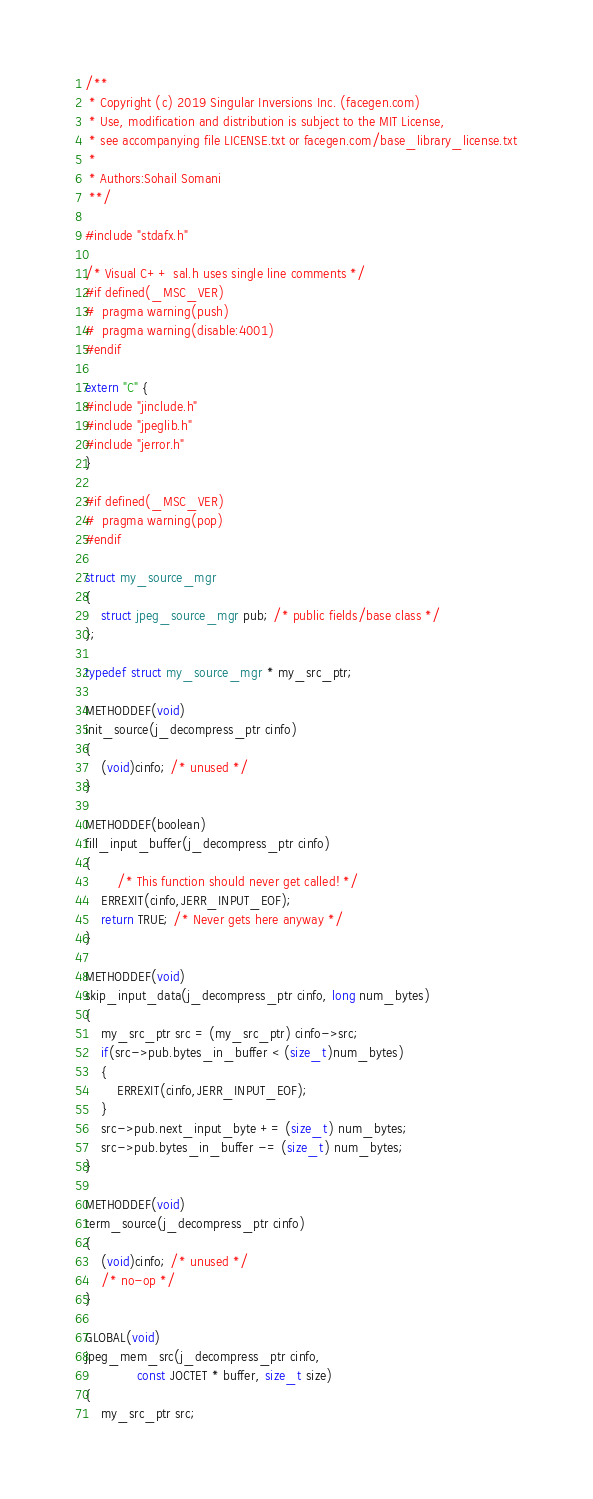<code> <loc_0><loc_0><loc_500><loc_500><_C++_>/**
 * Copyright (c) 2019 Singular Inversions Inc. (facegen.com)
 * Use, modification and distribution is subject to the MIT License,
 * see accompanying file LICENSE.txt or facegen.com/base_library_license.txt
 *
 * Authors:Sohail Somani
 **/

#include "stdafx.h"

/* Visual C++ sal.h uses single line comments */
#if defined(_MSC_VER)
#  pragma warning(push)
#  pragma warning(disable:4001)
#endif

extern "C" {
#include "jinclude.h"
#include "jpeglib.h"
#include "jerror.h"
}

#if defined(_MSC_VER)
#  pragma warning(pop)
#endif

struct my_source_mgr
{
    struct jpeg_source_mgr pub; /* public fields/base class */
};

typedef struct my_source_mgr * my_src_ptr;

METHODDEF(void)
init_source(j_decompress_ptr cinfo)
{
    (void)cinfo; /* unused */
}

METHODDEF(boolean)
fill_input_buffer(j_decompress_ptr cinfo)
{
        /* This function should never get called! */
    ERREXIT(cinfo,JERR_INPUT_EOF);
    return TRUE; /* Never gets here anyway */
}

METHODDEF(void)
skip_input_data(j_decompress_ptr cinfo, long num_bytes)
{
    my_src_ptr src = (my_src_ptr) cinfo->src;
    if(src->pub.bytes_in_buffer < (size_t)num_bytes)
    {
        ERREXIT(cinfo,JERR_INPUT_EOF);
    }
    src->pub.next_input_byte += (size_t) num_bytes;
    src->pub.bytes_in_buffer -= (size_t) num_bytes;
}

METHODDEF(void)
term_source(j_decompress_ptr cinfo)
{
    (void)cinfo; /* unused */
    /* no-op */
}

GLOBAL(void)
jpeg_mem_src(j_decompress_ptr cinfo,
             const JOCTET * buffer, size_t size)
{
    my_src_ptr src;</code> 